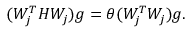<formula> <loc_0><loc_0><loc_500><loc_500>( W _ { j } ^ { T } H W _ { j } ) g = \theta ( W _ { j } ^ { T } W _ { j } ) g .</formula> 